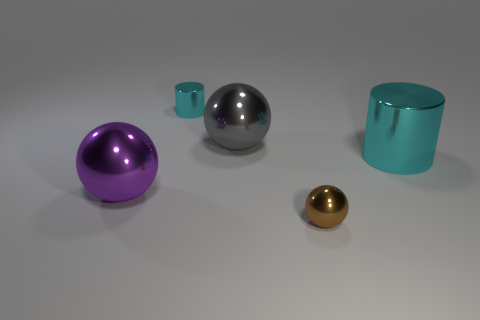Subtract all big gray spheres. How many spheres are left? 2 Add 4 small brown rubber objects. How many objects exist? 9 Subtract 1 spheres. How many spheres are left? 2 Subtract 0 green spheres. How many objects are left? 5 Subtract all balls. How many objects are left? 2 Subtract all purple spheres. Subtract all purple cylinders. How many spheres are left? 2 Subtract all large purple metallic things. Subtract all small things. How many objects are left? 2 Add 3 shiny things. How many shiny things are left? 8 Add 4 large cubes. How many large cubes exist? 4 